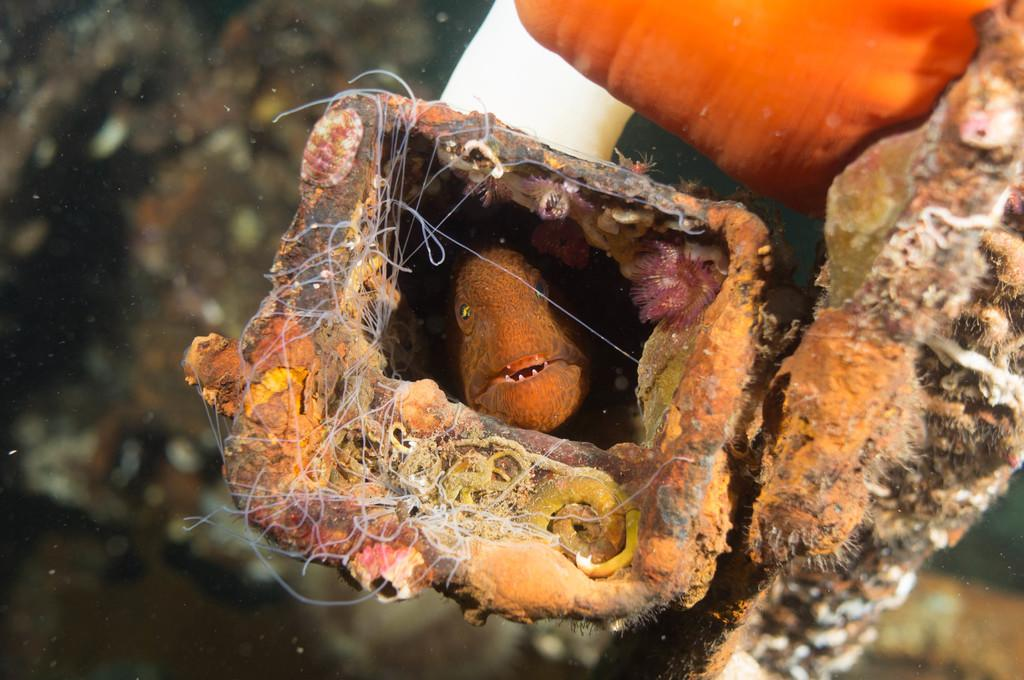What is in the water in the image? There is a fish in the water. What else can be seen in the image besides the fish? There are objects visible in the image. What colors are the objects in the image? The objects are orange and white in color. What type of show is being performed by the fish in the image? There is no show being performed by the fish in the image; it is simply swimming in the water. 